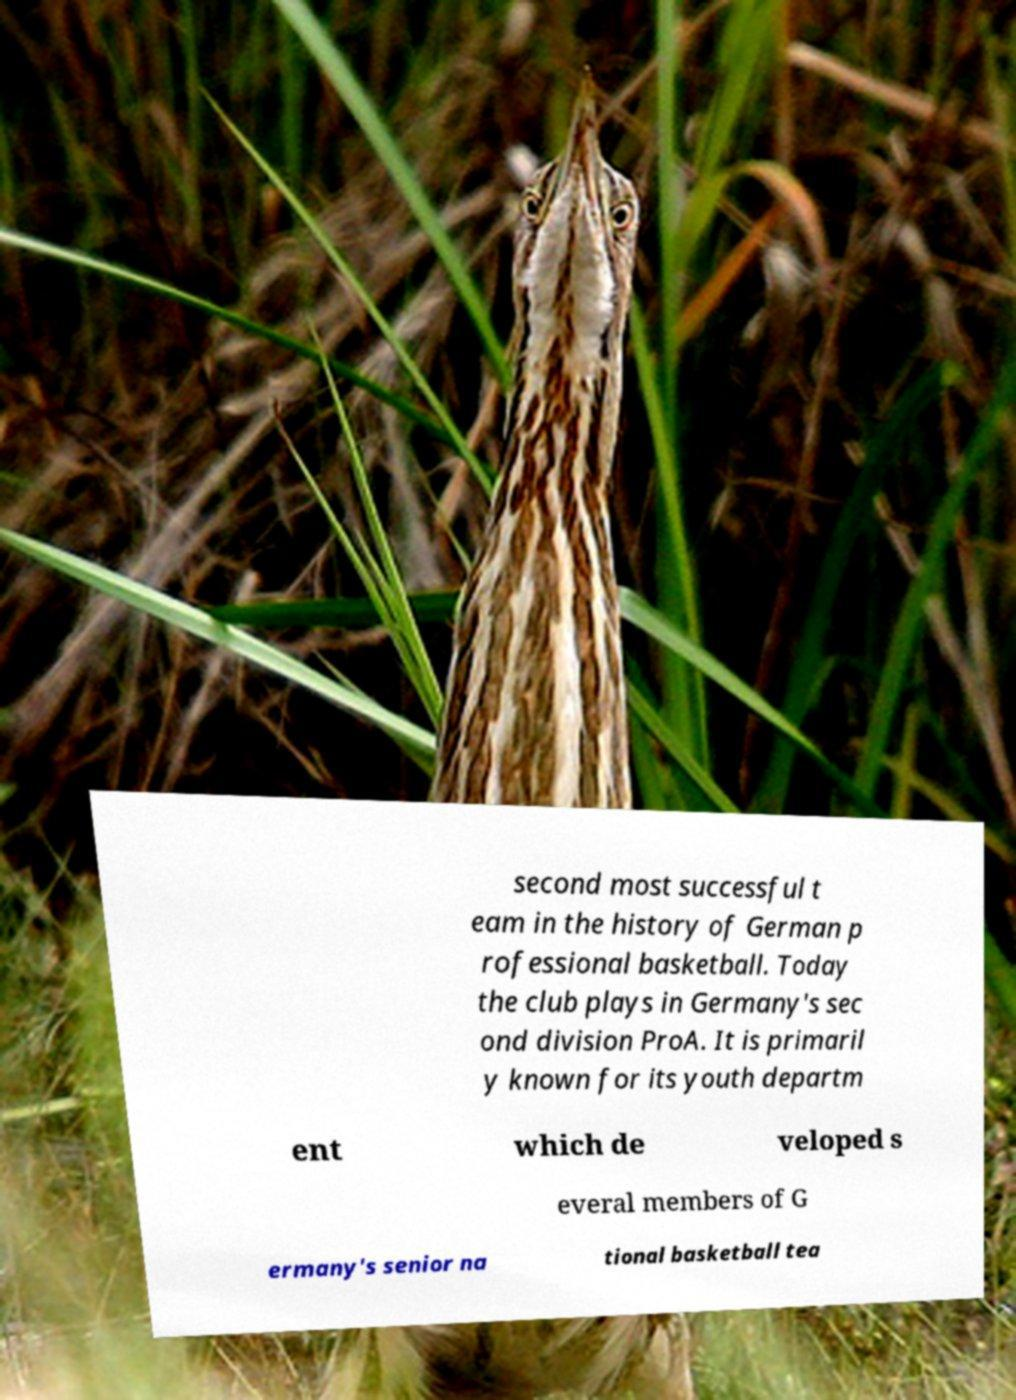I need the written content from this picture converted into text. Can you do that? second most successful t eam in the history of German p rofessional basketball. Today the club plays in Germany's sec ond division ProA. It is primaril y known for its youth departm ent which de veloped s everal members of G ermany's senior na tional basketball tea 